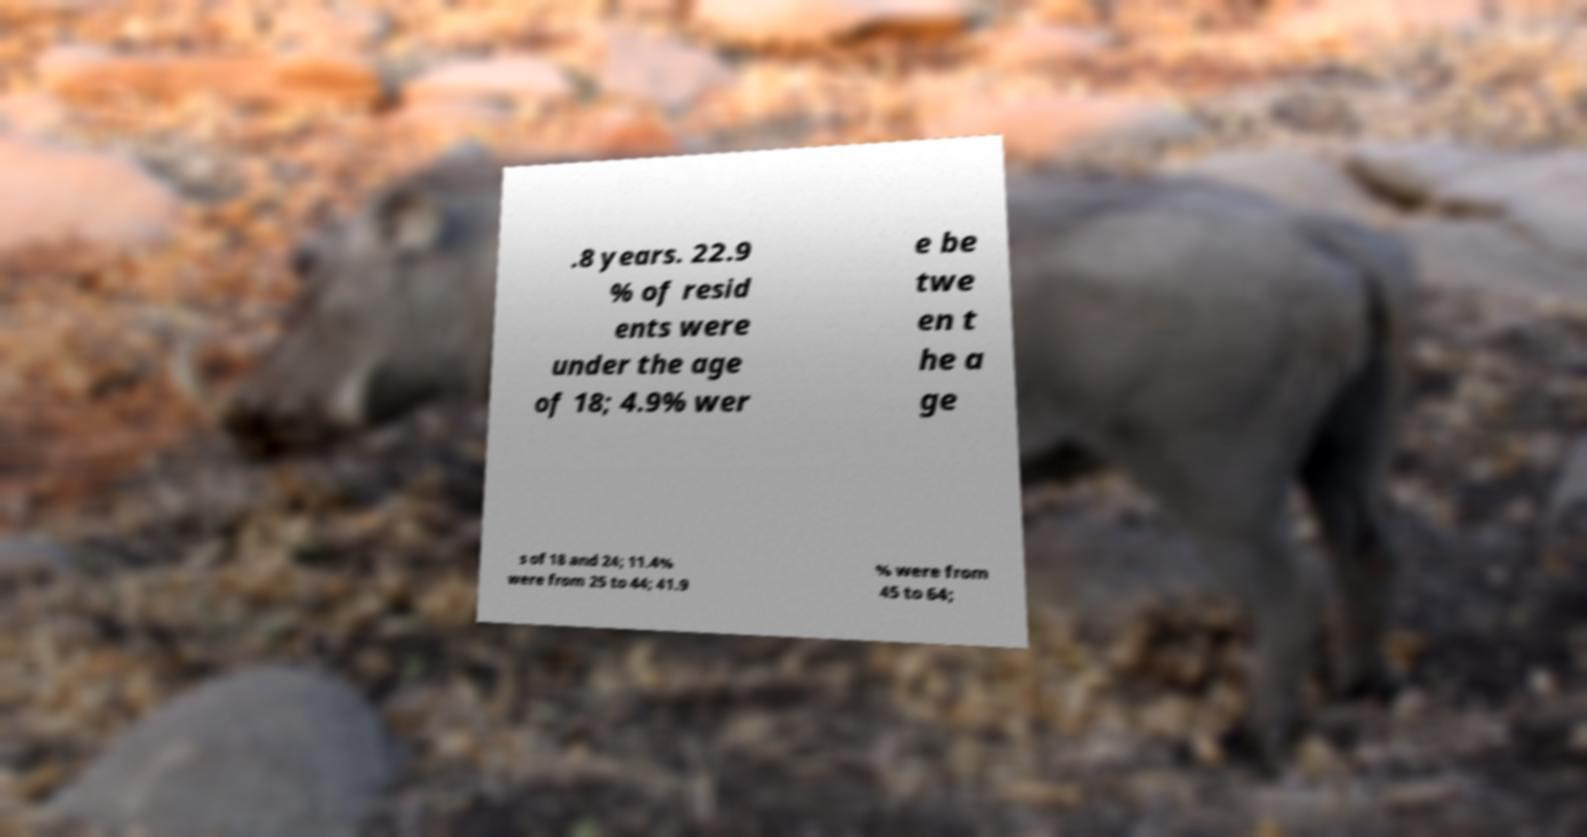I need the written content from this picture converted into text. Can you do that? .8 years. 22.9 % of resid ents were under the age of 18; 4.9% wer e be twe en t he a ge s of 18 and 24; 11.4% were from 25 to 44; 41.9 % were from 45 to 64; 